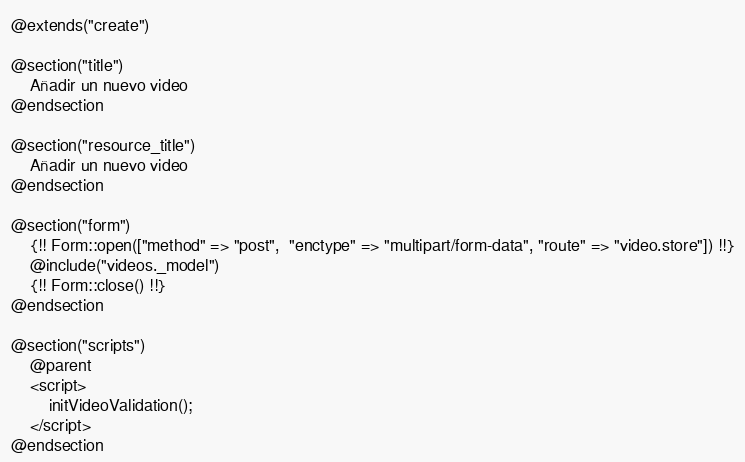<code> <loc_0><loc_0><loc_500><loc_500><_PHP_>@extends("create")

@section("title")
    Añadir un nuevo video
@endsection

@section("resource_title")
    Añadir un nuevo video
@endsection

@section("form")
    {!! Form::open(["method" => "post",  "enctype" => "multipart/form-data", "route" => "video.store"]) !!}
    @include("videos._model")
    {!! Form::close() !!}
@endsection

@section("scripts")
    @parent
    <script>
        initVideoValidation();
    </script>
@endsection</code> 